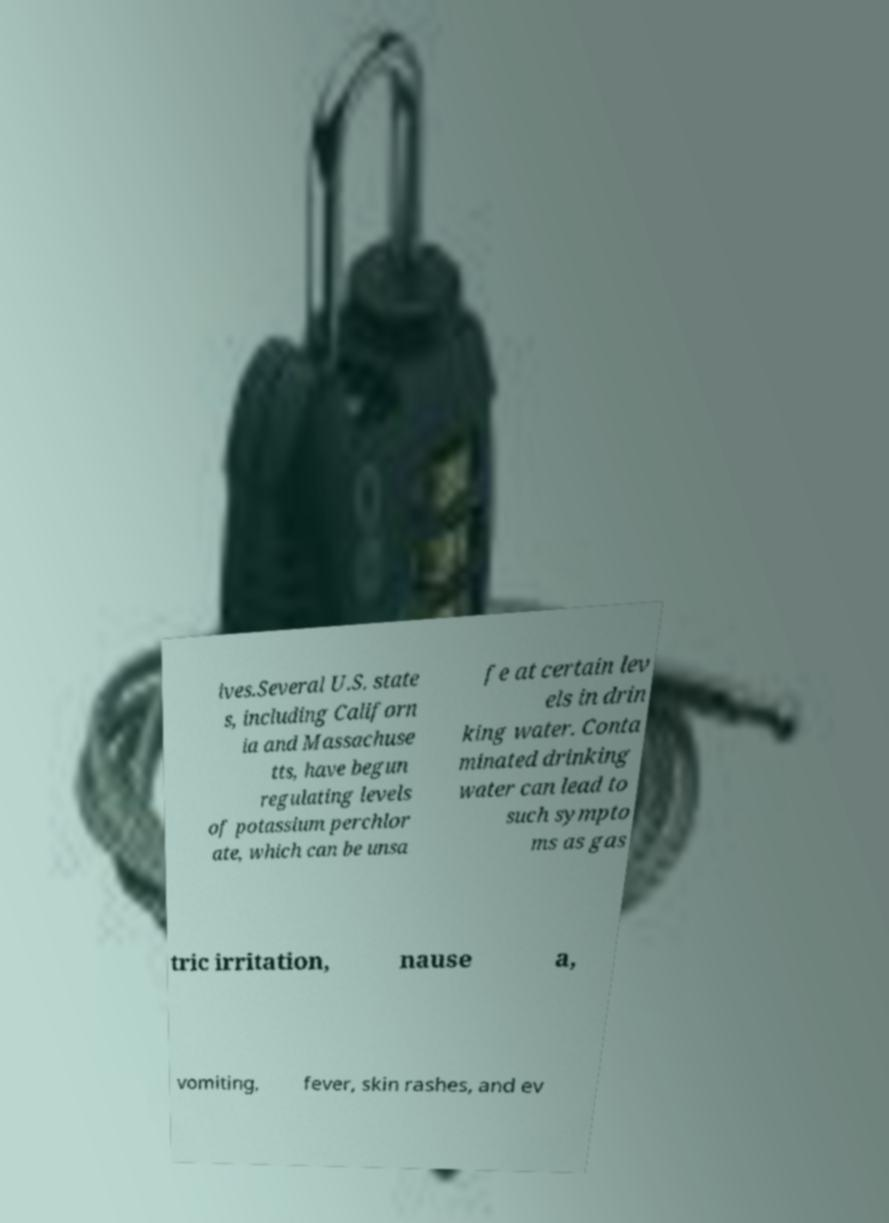Can you accurately transcribe the text from the provided image for me? ives.Several U.S. state s, including Californ ia and Massachuse tts, have begun regulating levels of potassium perchlor ate, which can be unsa fe at certain lev els in drin king water. Conta minated drinking water can lead to such sympto ms as gas tric irritation, nause a, vomiting, fever, skin rashes, and ev 